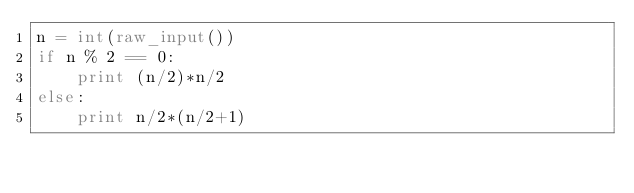<code> <loc_0><loc_0><loc_500><loc_500><_Python_>n = int(raw_input())
if n % 2 == 0:
    print (n/2)*n/2
else:
    print n/2*(n/2+1)</code> 